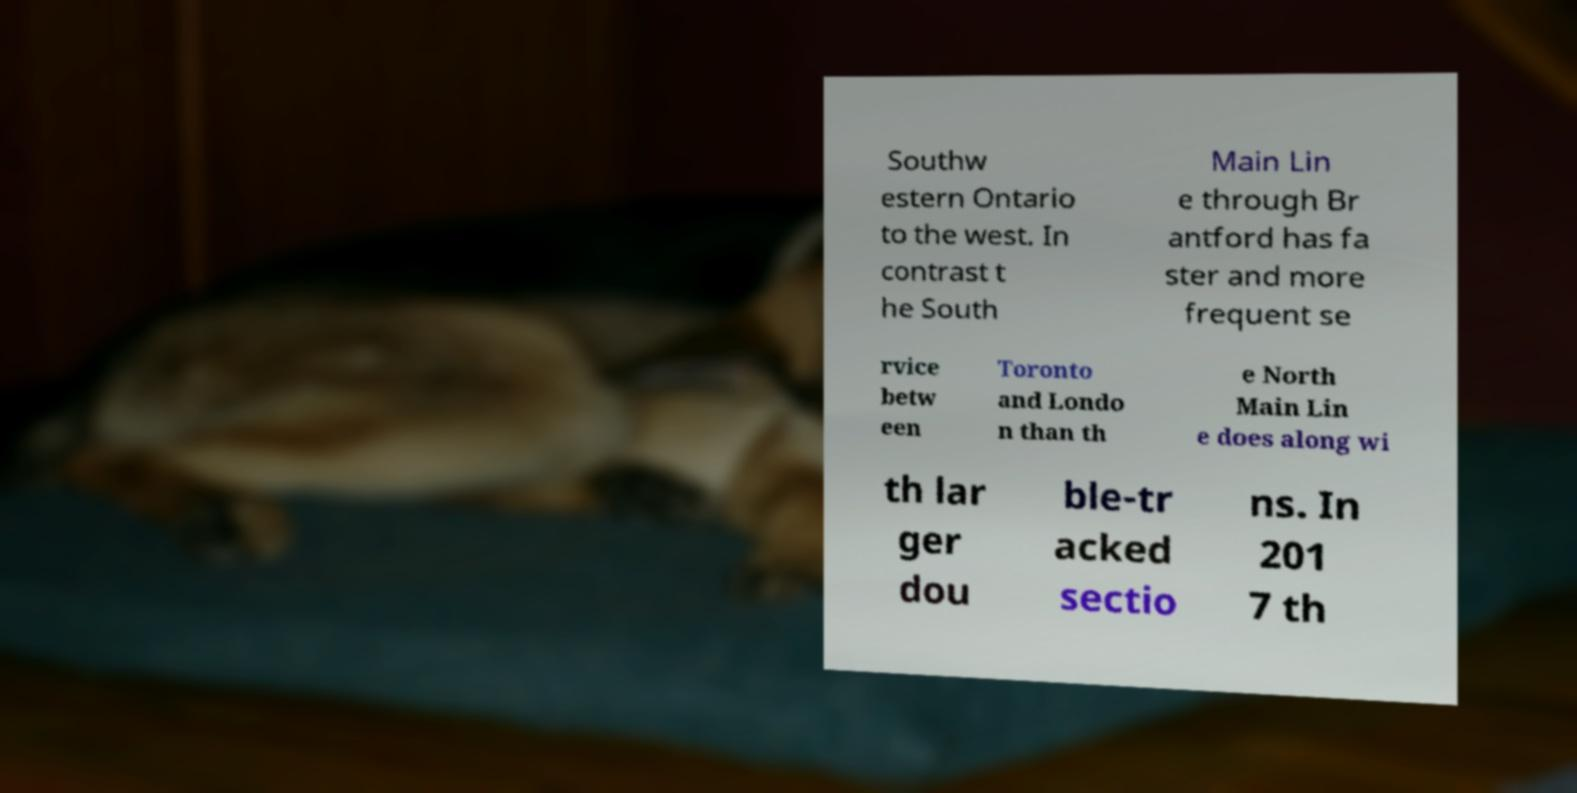What messages or text are displayed in this image? I need them in a readable, typed format. Southw estern Ontario to the west. In contrast t he South Main Lin e through Br antford has fa ster and more frequent se rvice betw een Toronto and Londo n than th e North Main Lin e does along wi th lar ger dou ble-tr acked sectio ns. In 201 7 th 